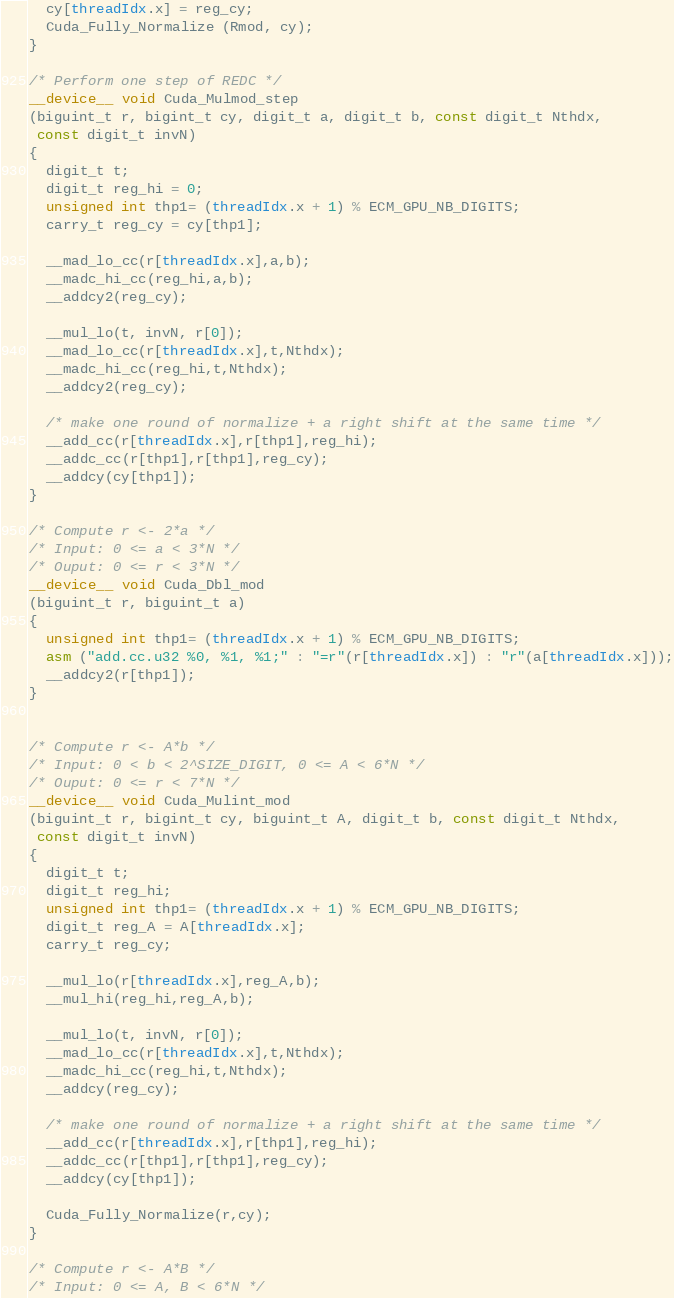<code> <loc_0><loc_0><loc_500><loc_500><_Cuda_>  cy[threadIdx.x] = reg_cy;
  Cuda_Fully_Normalize (Rmod, cy); 
}

/* Perform one step of REDC */ 
__device__ void Cuda_Mulmod_step
(biguint_t r, bigint_t cy, digit_t a, digit_t b, const digit_t Nthdx,
 const digit_t invN)
{
  digit_t t;
  digit_t reg_hi = 0;
  unsigned int thp1= (threadIdx.x + 1) % ECM_GPU_NB_DIGITS;
  carry_t reg_cy = cy[thp1];

  __mad_lo_cc(r[threadIdx.x],a,b);
  __madc_hi_cc(reg_hi,a,b);
  __addcy2(reg_cy);

  __mul_lo(t, invN, r[0]);
  __mad_lo_cc(r[threadIdx.x],t,Nthdx);
  __madc_hi_cc(reg_hi,t,Nthdx);
  __addcy2(reg_cy);

  /* make one round of normalize + a right shift at the same time */
  __add_cc(r[threadIdx.x],r[thp1],reg_hi);
  __addc_cc(r[thp1],r[thp1],reg_cy);
  __addcy(cy[thp1]); 
}

/* Compute r <- 2*a */ 
/* Input: 0 <= a < 3*N */ 
/* Ouput: 0 <= r < 3*N */ 
__device__ void Cuda_Dbl_mod
(biguint_t r, biguint_t a)
{
  unsigned int thp1= (threadIdx.x + 1) % ECM_GPU_NB_DIGITS;
  asm ("add.cc.u32 %0, %1, %1;" : "=r"(r[threadIdx.x]) : "r"(a[threadIdx.x]));
  __addcy2(r[thp1]);
}


/* Compute r <- A*b */ 
/* Input: 0 < b < 2^SIZE_DIGIT, 0 <= A < 6*N */ 
/* Ouput: 0 <= r < 7*N */ 
__device__ void Cuda_Mulint_mod
(biguint_t r, bigint_t cy, biguint_t A, digit_t b, const digit_t Nthdx,
 const digit_t invN)
{
  digit_t t;
  digit_t reg_hi;
  unsigned int thp1= (threadIdx.x + 1) % ECM_GPU_NB_DIGITS;
  digit_t reg_A = A[threadIdx.x];
  carry_t reg_cy;

  __mul_lo(r[threadIdx.x],reg_A,b);
  __mul_hi(reg_hi,reg_A,b);

  __mul_lo(t, invN, r[0]);
  __mad_lo_cc(r[threadIdx.x],t,Nthdx);
  __madc_hi_cc(reg_hi,t,Nthdx);
  __addcy(reg_cy);

  /* make one round of normalize + a right shift at the same time */
  __add_cc(r[threadIdx.x],r[thp1],reg_hi);
  __addc_cc(r[thp1],r[thp1],reg_cy);
  __addcy(cy[thp1]); 

  Cuda_Fully_Normalize(r,cy); 
}

/* Compute r <- A*B */ 
/* Input: 0 <= A, B < 6*N */</code> 